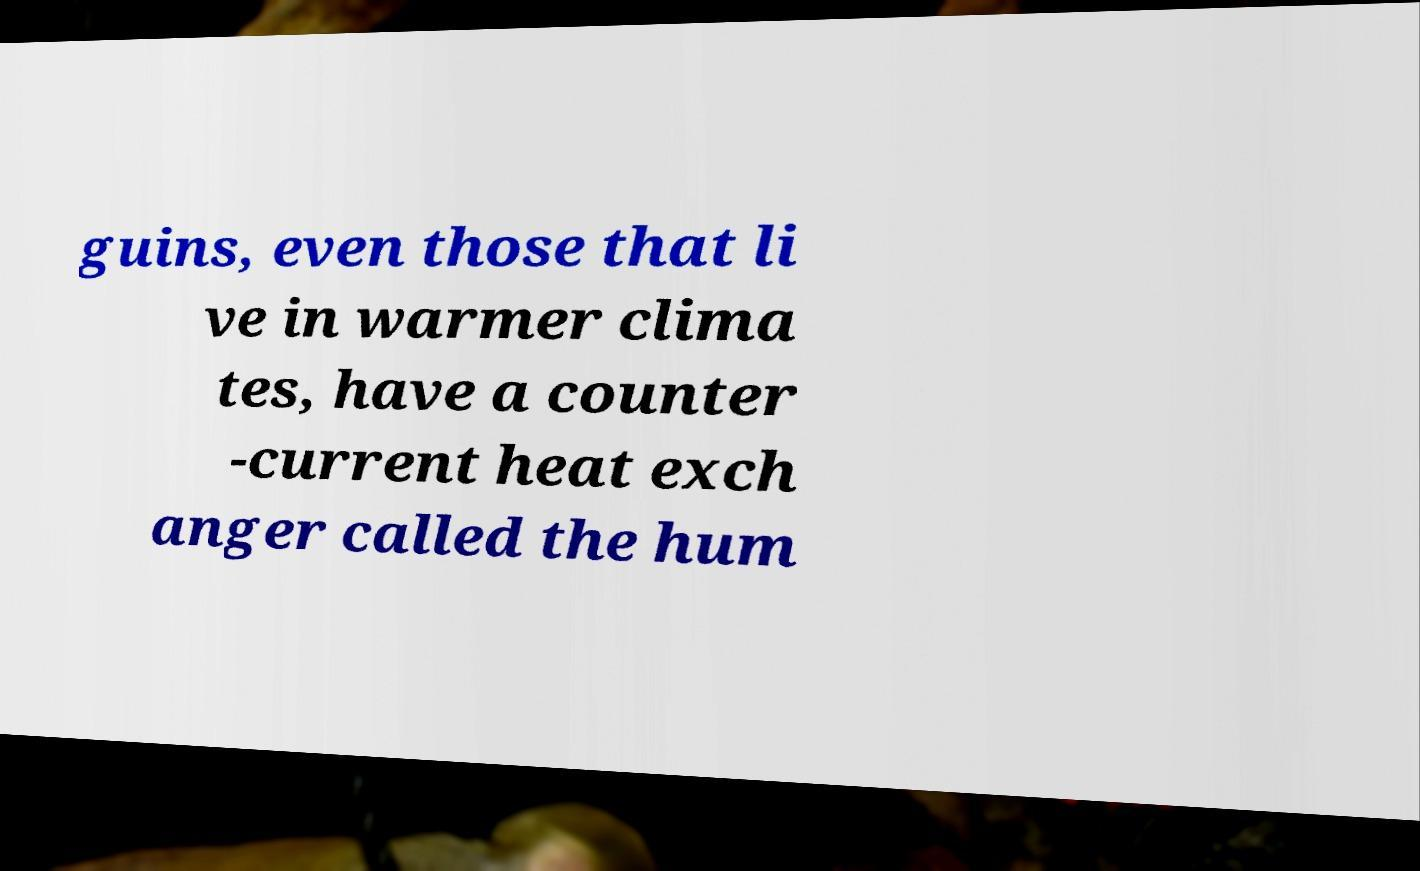I need the written content from this picture converted into text. Can you do that? guins, even those that li ve in warmer clima tes, have a counter -current heat exch anger called the hum 